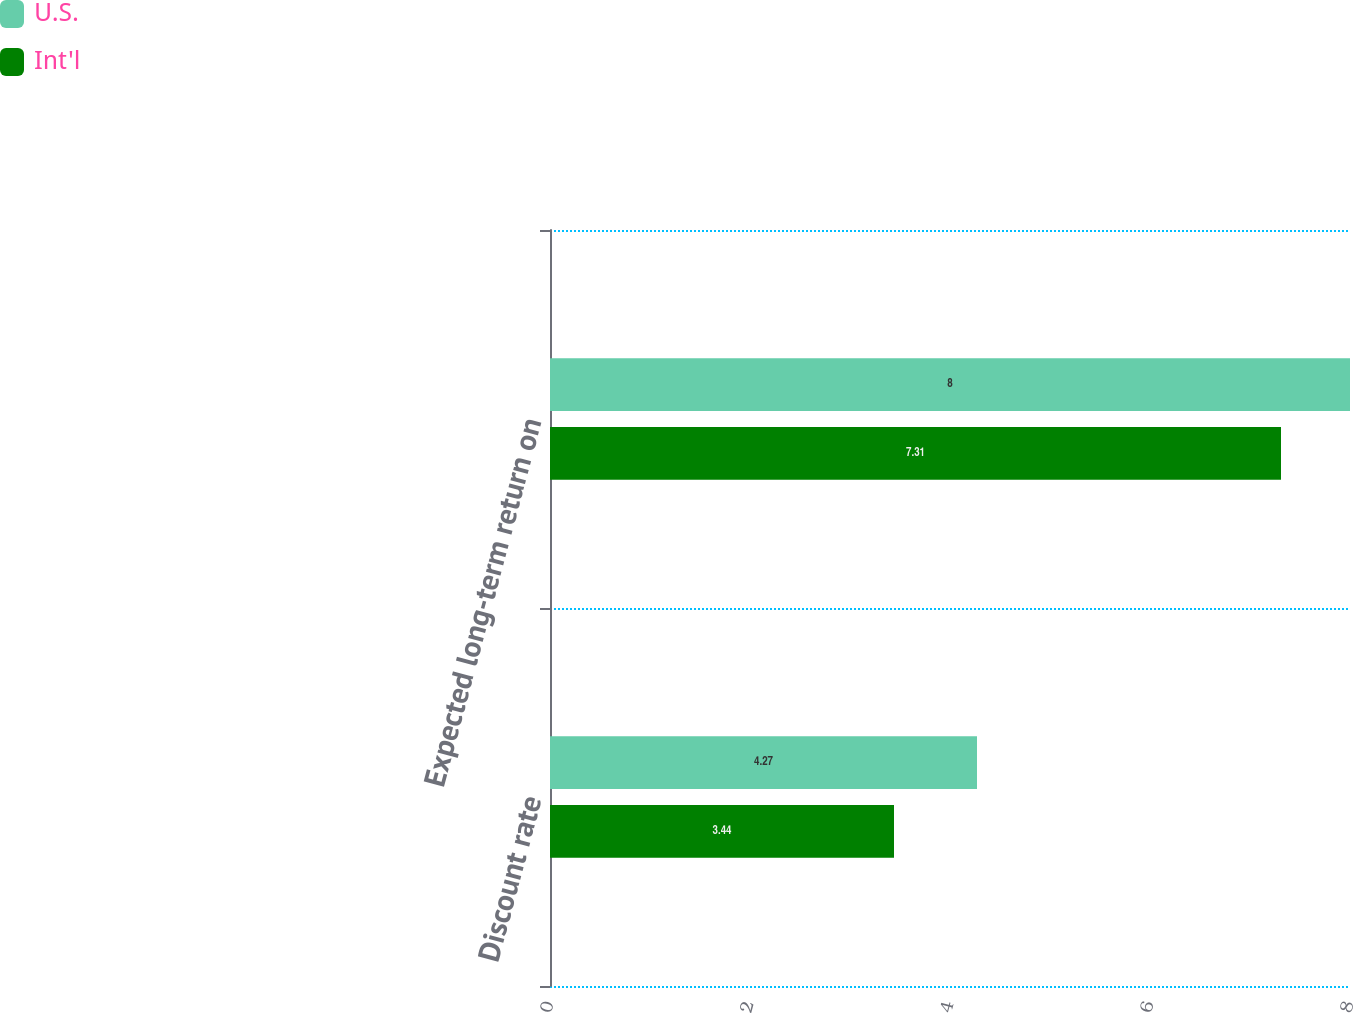Convert chart to OTSL. <chart><loc_0><loc_0><loc_500><loc_500><stacked_bar_chart><ecel><fcel>Discount rate<fcel>Expected long-term return on<nl><fcel>U.S.<fcel>4.27<fcel>8<nl><fcel>Int'l<fcel>3.44<fcel>7.31<nl></chart> 